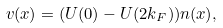<formula> <loc_0><loc_0><loc_500><loc_500>v ( x ) = ( U ( 0 ) - U ( 2 k _ { F } ) ) n ( x ) ,</formula> 